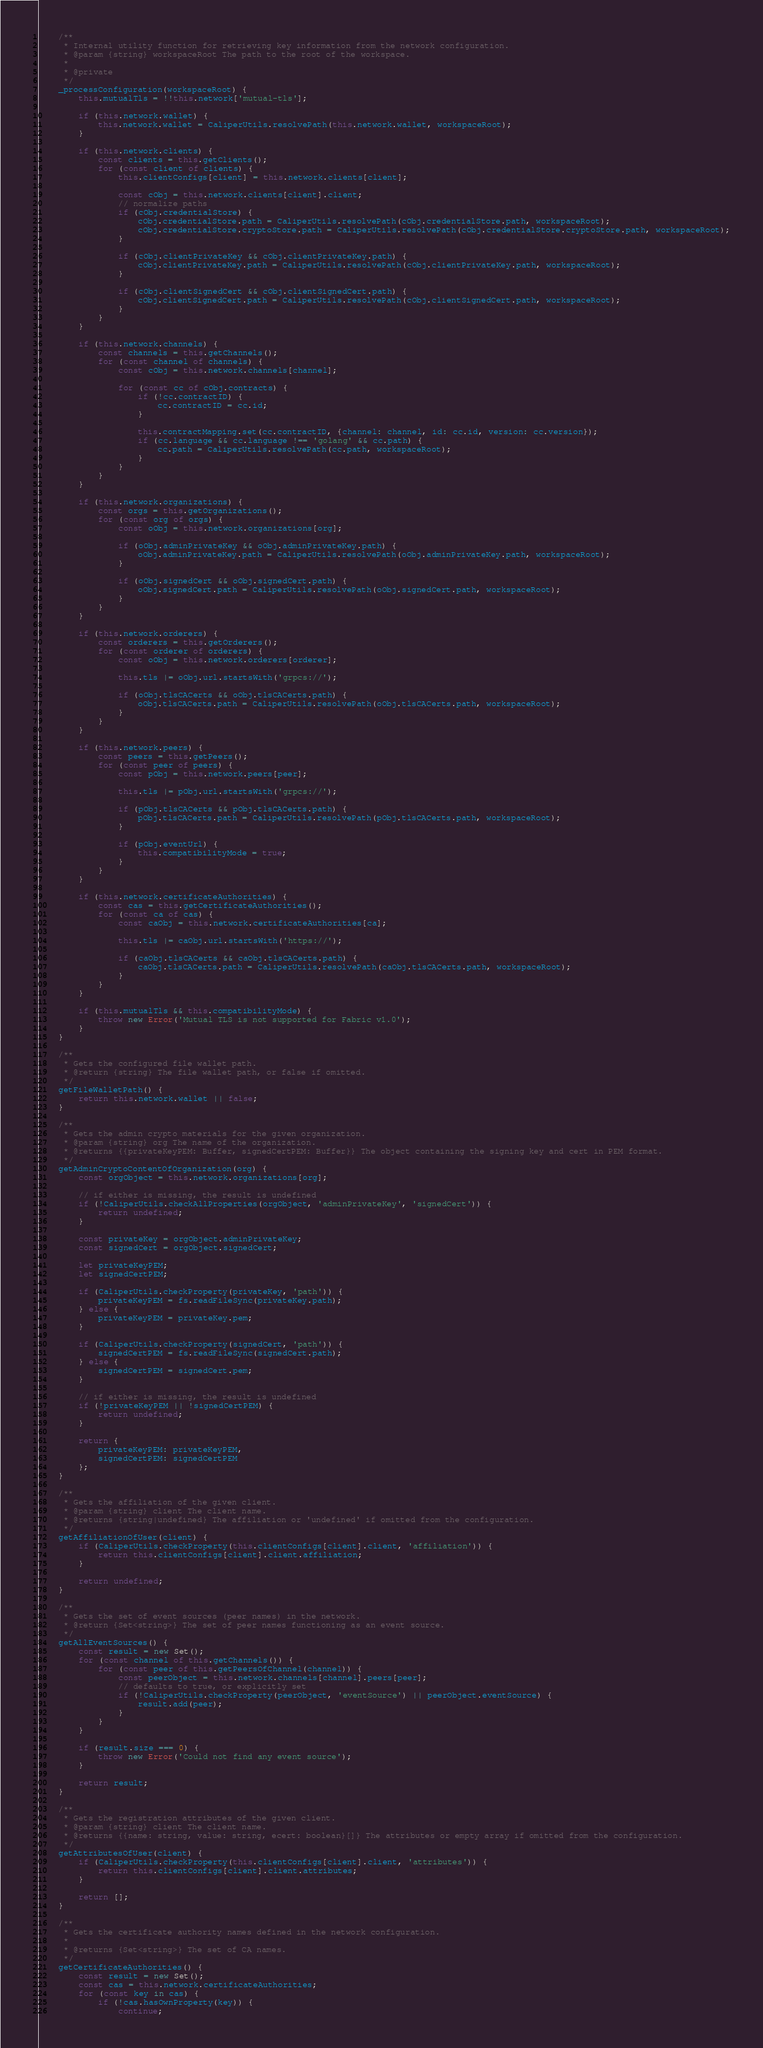<code> <loc_0><loc_0><loc_500><loc_500><_JavaScript_>
    /**
     * Internal utility function for retrieving key information from the network configuration.
     * @param {string} workspaceRoot The path to the root of the workspace.
     *
     * @private
     */
    _processConfiguration(workspaceRoot) {
        this.mutualTls = !!this.network['mutual-tls'];

        if (this.network.wallet) {
            this.network.wallet = CaliperUtils.resolvePath(this.network.wallet, workspaceRoot);
        }

        if (this.network.clients) {
            const clients = this.getClients();
            for (const client of clients) {
                this.clientConfigs[client] = this.network.clients[client];

                const cObj = this.network.clients[client].client;
                // normalize paths
                if (cObj.credentialStore) {
                    cObj.credentialStore.path = CaliperUtils.resolvePath(cObj.credentialStore.path, workspaceRoot);
                    cObj.credentialStore.cryptoStore.path = CaliperUtils.resolvePath(cObj.credentialStore.cryptoStore.path, workspaceRoot);
                }

                if (cObj.clientPrivateKey && cObj.clientPrivateKey.path) {
                    cObj.clientPrivateKey.path = CaliperUtils.resolvePath(cObj.clientPrivateKey.path, workspaceRoot);
                }

                if (cObj.clientSignedCert && cObj.clientSignedCert.path) {
                    cObj.clientSignedCert.path = CaliperUtils.resolvePath(cObj.clientSignedCert.path, workspaceRoot);
                }
            }
        }

        if (this.network.channels) {
            const channels = this.getChannels();
            for (const channel of channels) {
                const cObj = this.network.channels[channel];

                for (const cc of cObj.contracts) {
                    if (!cc.contractID) {
                        cc.contractID = cc.id;
                    }

                    this.contractMapping.set(cc.contractID, {channel: channel, id: cc.id, version: cc.version});
                    if (cc.language && cc.language !== 'golang' && cc.path) {
                        cc.path = CaliperUtils.resolvePath(cc.path, workspaceRoot);
                    }
                }
            }
        }

        if (this.network.organizations) {
            const orgs = this.getOrganizations();
            for (const org of orgs) {
                const oObj = this.network.organizations[org];

                if (oObj.adminPrivateKey && oObj.adminPrivateKey.path) {
                    oObj.adminPrivateKey.path = CaliperUtils.resolvePath(oObj.adminPrivateKey.path, workspaceRoot);
                }

                if (oObj.signedCert && oObj.signedCert.path) {
                    oObj.signedCert.path = CaliperUtils.resolvePath(oObj.signedCert.path, workspaceRoot);
                }
            }
        }

        if (this.network.orderers) {
            const orderers = this.getOrderers();
            for (const orderer of orderers) {
                const oObj = this.network.orderers[orderer];

                this.tls |= oObj.url.startsWith('grpcs://');

                if (oObj.tlsCACerts && oObj.tlsCACerts.path) {
                    oObj.tlsCACerts.path = CaliperUtils.resolvePath(oObj.tlsCACerts.path, workspaceRoot);
                }
            }
        }

        if (this.network.peers) {
            const peers = this.getPeers();
            for (const peer of peers) {
                const pObj = this.network.peers[peer];

                this.tls |= pObj.url.startsWith('grpcs://');

                if (pObj.tlsCACerts && pObj.tlsCACerts.path) {
                    pObj.tlsCACerts.path = CaliperUtils.resolvePath(pObj.tlsCACerts.path, workspaceRoot);
                }

                if (pObj.eventUrl) {
                    this.compatibilityMode = true;
                }
            }
        }

        if (this.network.certificateAuthorities) {
            const cas = this.getCertificateAuthorities();
            for (const ca of cas) {
                const caObj = this.network.certificateAuthorities[ca];

                this.tls |= caObj.url.startsWith('https://');

                if (caObj.tlsCACerts && caObj.tlsCACerts.path) {
                    caObj.tlsCACerts.path = CaliperUtils.resolvePath(caObj.tlsCACerts.path, workspaceRoot);
                }
            }
        }

        if (this.mutualTls && this.compatibilityMode) {
            throw new Error('Mutual TLS is not supported for Fabric v1.0');
        }
    }

    /**
     * Gets the configured file wallet path.
     * @return {string} The file wallet path, or false if omitted.
     */
    getFileWalletPath() {
        return this.network.wallet || false;
    }

    /**
     * Gets the admin crypto materials for the given organization.
     * @param {string} org The name of the organization.
     * @returns {{privateKeyPEM: Buffer, signedCertPEM: Buffer}} The object containing the signing key and cert in PEM format.
     */
    getAdminCryptoContentOfOrganization(org) {
        const orgObject = this.network.organizations[org];

        // if either is missing, the result is undefined
        if (!CaliperUtils.checkAllProperties(orgObject, 'adminPrivateKey', 'signedCert')) {
            return undefined;
        }

        const privateKey = orgObject.adminPrivateKey;
        const signedCert = orgObject.signedCert;

        let privateKeyPEM;
        let signedCertPEM;

        if (CaliperUtils.checkProperty(privateKey, 'path')) {
            privateKeyPEM = fs.readFileSync(privateKey.path);
        } else {
            privateKeyPEM = privateKey.pem;
        }

        if (CaliperUtils.checkProperty(signedCert, 'path')) {
            signedCertPEM = fs.readFileSync(signedCert.path);
        } else {
            signedCertPEM = signedCert.pem;
        }

        // if either is missing, the result is undefined
        if (!privateKeyPEM || !signedCertPEM) {
            return undefined;
        }

        return {
            privateKeyPEM: privateKeyPEM,
            signedCertPEM: signedCertPEM
        };
    }

    /**
     * Gets the affiliation of the given client.
     * @param {string} client The client name.
     * @returns {string|undefined} The affiliation or 'undefined' if omitted from the configuration.
     */
    getAffiliationOfUser(client) {
        if (CaliperUtils.checkProperty(this.clientConfigs[client].client, 'affiliation')) {
            return this.clientConfigs[client].client.affiliation;
        }

        return undefined;
    }

    /**
     * Gets the set of event sources (peer names) in the network.
     * @return {Set<string>} The set of peer names functioning as an event source.
     */
    getAllEventSources() {
        const result = new Set();
        for (const channel of this.getChannels()) {
            for (const peer of this.getPeersOfChannel(channel)) {
                const peerObject = this.network.channels[channel].peers[peer];
                // defaults to true, or explicitly set
                if (!CaliperUtils.checkProperty(peerObject, 'eventSource') || peerObject.eventSource) {
                    result.add(peer);
                }
            }
        }

        if (result.size === 0) {
            throw new Error('Could not find any event source');
        }

        return result;
    }

    /**
     * Gets the registration attributes of the given client.
     * @param {string} client The client name.
     * @returns {{name: string, value: string, ecert: boolean}[]} The attributes or empty array if omitted from the configuration.
     */
    getAttributesOfUser(client) {
        if (CaliperUtils.checkProperty(this.clientConfigs[client].client, 'attributes')) {
            return this.clientConfigs[client].client.attributes;
        }

        return [];
    }

    /**
     * Gets the certificate authority names defined in the network configuration.
     *
     * @returns {Set<string>} The set of CA names.
     */
    getCertificateAuthorities() {
        const result = new Set();
        const cas = this.network.certificateAuthorities;
        for (const key in cas) {
            if (!cas.hasOwnProperty(key)) {
                continue;</code> 